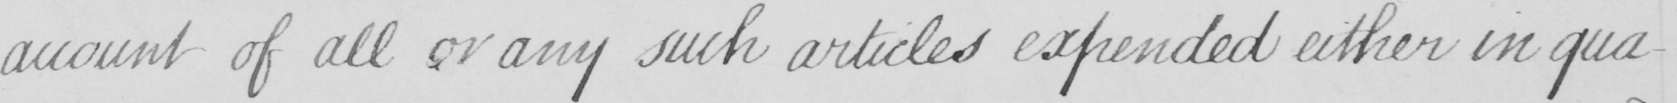What is written in this line of handwriting? account of all or any such articles expended either in qua- 